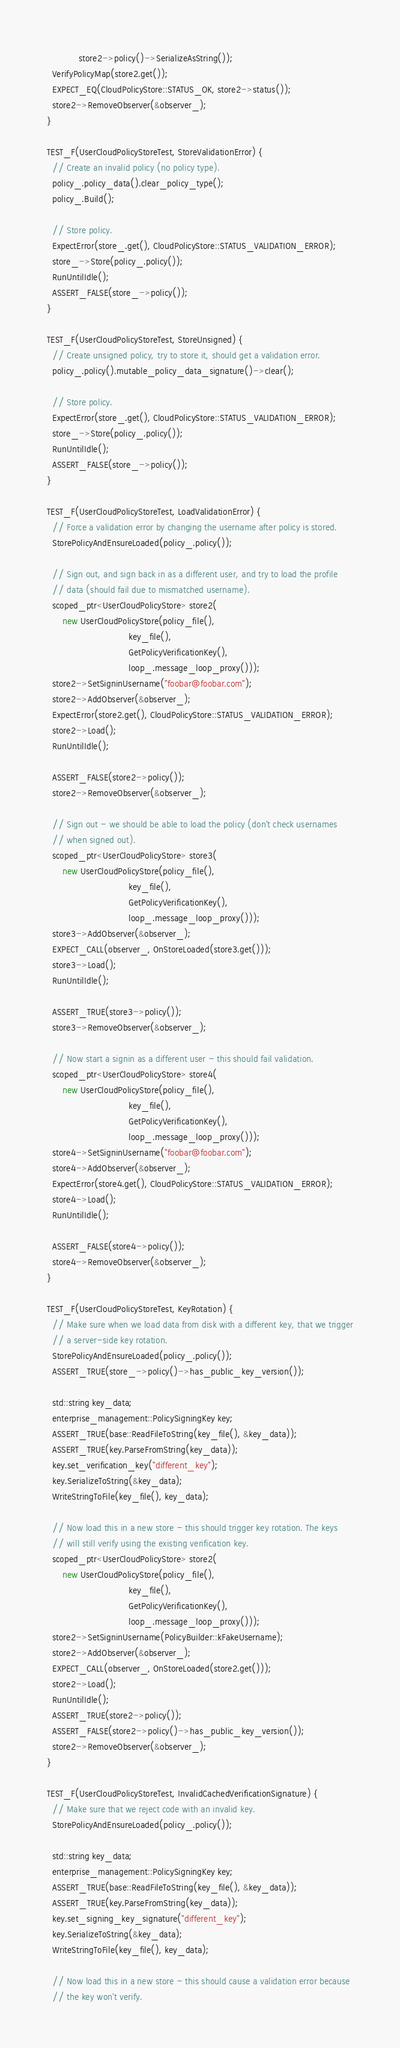Convert code to text. <code><loc_0><loc_0><loc_500><loc_500><_C++_>            store2->policy()->SerializeAsString());
  VerifyPolicyMap(store2.get());
  EXPECT_EQ(CloudPolicyStore::STATUS_OK, store2->status());
  store2->RemoveObserver(&observer_);
}

TEST_F(UserCloudPolicyStoreTest, StoreValidationError) {
  // Create an invalid policy (no policy type).
  policy_.policy_data().clear_policy_type();
  policy_.Build();

  // Store policy.
  ExpectError(store_.get(), CloudPolicyStore::STATUS_VALIDATION_ERROR);
  store_->Store(policy_.policy());
  RunUntilIdle();
  ASSERT_FALSE(store_->policy());
}

TEST_F(UserCloudPolicyStoreTest, StoreUnsigned) {
  // Create unsigned policy, try to store it, should get a validation error.
  policy_.policy().mutable_policy_data_signature()->clear();

  // Store policy.
  ExpectError(store_.get(), CloudPolicyStore::STATUS_VALIDATION_ERROR);
  store_->Store(policy_.policy());
  RunUntilIdle();
  ASSERT_FALSE(store_->policy());
}

TEST_F(UserCloudPolicyStoreTest, LoadValidationError) {
  // Force a validation error by changing the username after policy is stored.
  StorePolicyAndEnsureLoaded(policy_.policy());

  // Sign out, and sign back in as a different user, and try to load the profile
  // data (should fail due to mismatched username).
  scoped_ptr<UserCloudPolicyStore> store2(
      new UserCloudPolicyStore(policy_file(),
                               key_file(),
                               GetPolicyVerificationKey(),
                               loop_.message_loop_proxy()));
  store2->SetSigninUsername("foobar@foobar.com");
  store2->AddObserver(&observer_);
  ExpectError(store2.get(), CloudPolicyStore::STATUS_VALIDATION_ERROR);
  store2->Load();
  RunUntilIdle();

  ASSERT_FALSE(store2->policy());
  store2->RemoveObserver(&observer_);

  // Sign out - we should be able to load the policy (don't check usernames
  // when signed out).
  scoped_ptr<UserCloudPolicyStore> store3(
      new UserCloudPolicyStore(policy_file(),
                               key_file(),
                               GetPolicyVerificationKey(),
                               loop_.message_loop_proxy()));
  store3->AddObserver(&observer_);
  EXPECT_CALL(observer_, OnStoreLoaded(store3.get()));
  store3->Load();
  RunUntilIdle();

  ASSERT_TRUE(store3->policy());
  store3->RemoveObserver(&observer_);

  // Now start a signin as a different user - this should fail validation.
  scoped_ptr<UserCloudPolicyStore> store4(
      new UserCloudPolicyStore(policy_file(),
                               key_file(),
                               GetPolicyVerificationKey(),
                               loop_.message_loop_proxy()));
  store4->SetSigninUsername("foobar@foobar.com");
  store4->AddObserver(&observer_);
  ExpectError(store4.get(), CloudPolicyStore::STATUS_VALIDATION_ERROR);
  store4->Load();
  RunUntilIdle();

  ASSERT_FALSE(store4->policy());
  store4->RemoveObserver(&observer_);
}

TEST_F(UserCloudPolicyStoreTest, KeyRotation) {
  // Make sure when we load data from disk with a different key, that we trigger
  // a server-side key rotation.
  StorePolicyAndEnsureLoaded(policy_.policy());
  ASSERT_TRUE(store_->policy()->has_public_key_version());

  std::string key_data;
  enterprise_management::PolicySigningKey key;
  ASSERT_TRUE(base::ReadFileToString(key_file(), &key_data));
  ASSERT_TRUE(key.ParseFromString(key_data));
  key.set_verification_key("different_key");
  key.SerializeToString(&key_data);
  WriteStringToFile(key_file(), key_data);

  // Now load this in a new store - this should trigger key rotation. The keys
  // will still verify using the existing verification key.
  scoped_ptr<UserCloudPolicyStore> store2(
      new UserCloudPolicyStore(policy_file(),
                               key_file(),
                               GetPolicyVerificationKey(),
                               loop_.message_loop_proxy()));
  store2->SetSigninUsername(PolicyBuilder::kFakeUsername);
  store2->AddObserver(&observer_);
  EXPECT_CALL(observer_, OnStoreLoaded(store2.get()));
  store2->Load();
  RunUntilIdle();
  ASSERT_TRUE(store2->policy());
  ASSERT_FALSE(store2->policy()->has_public_key_version());
  store2->RemoveObserver(&observer_);
}

TEST_F(UserCloudPolicyStoreTest, InvalidCachedVerificationSignature) {
  // Make sure that we reject code with an invalid key.
  StorePolicyAndEnsureLoaded(policy_.policy());

  std::string key_data;
  enterprise_management::PolicySigningKey key;
  ASSERT_TRUE(base::ReadFileToString(key_file(), &key_data));
  ASSERT_TRUE(key.ParseFromString(key_data));
  key.set_signing_key_signature("different_key");
  key.SerializeToString(&key_data);
  WriteStringToFile(key_file(), key_data);

  // Now load this in a new store - this should cause a validation error because
  // the key won't verify.</code> 